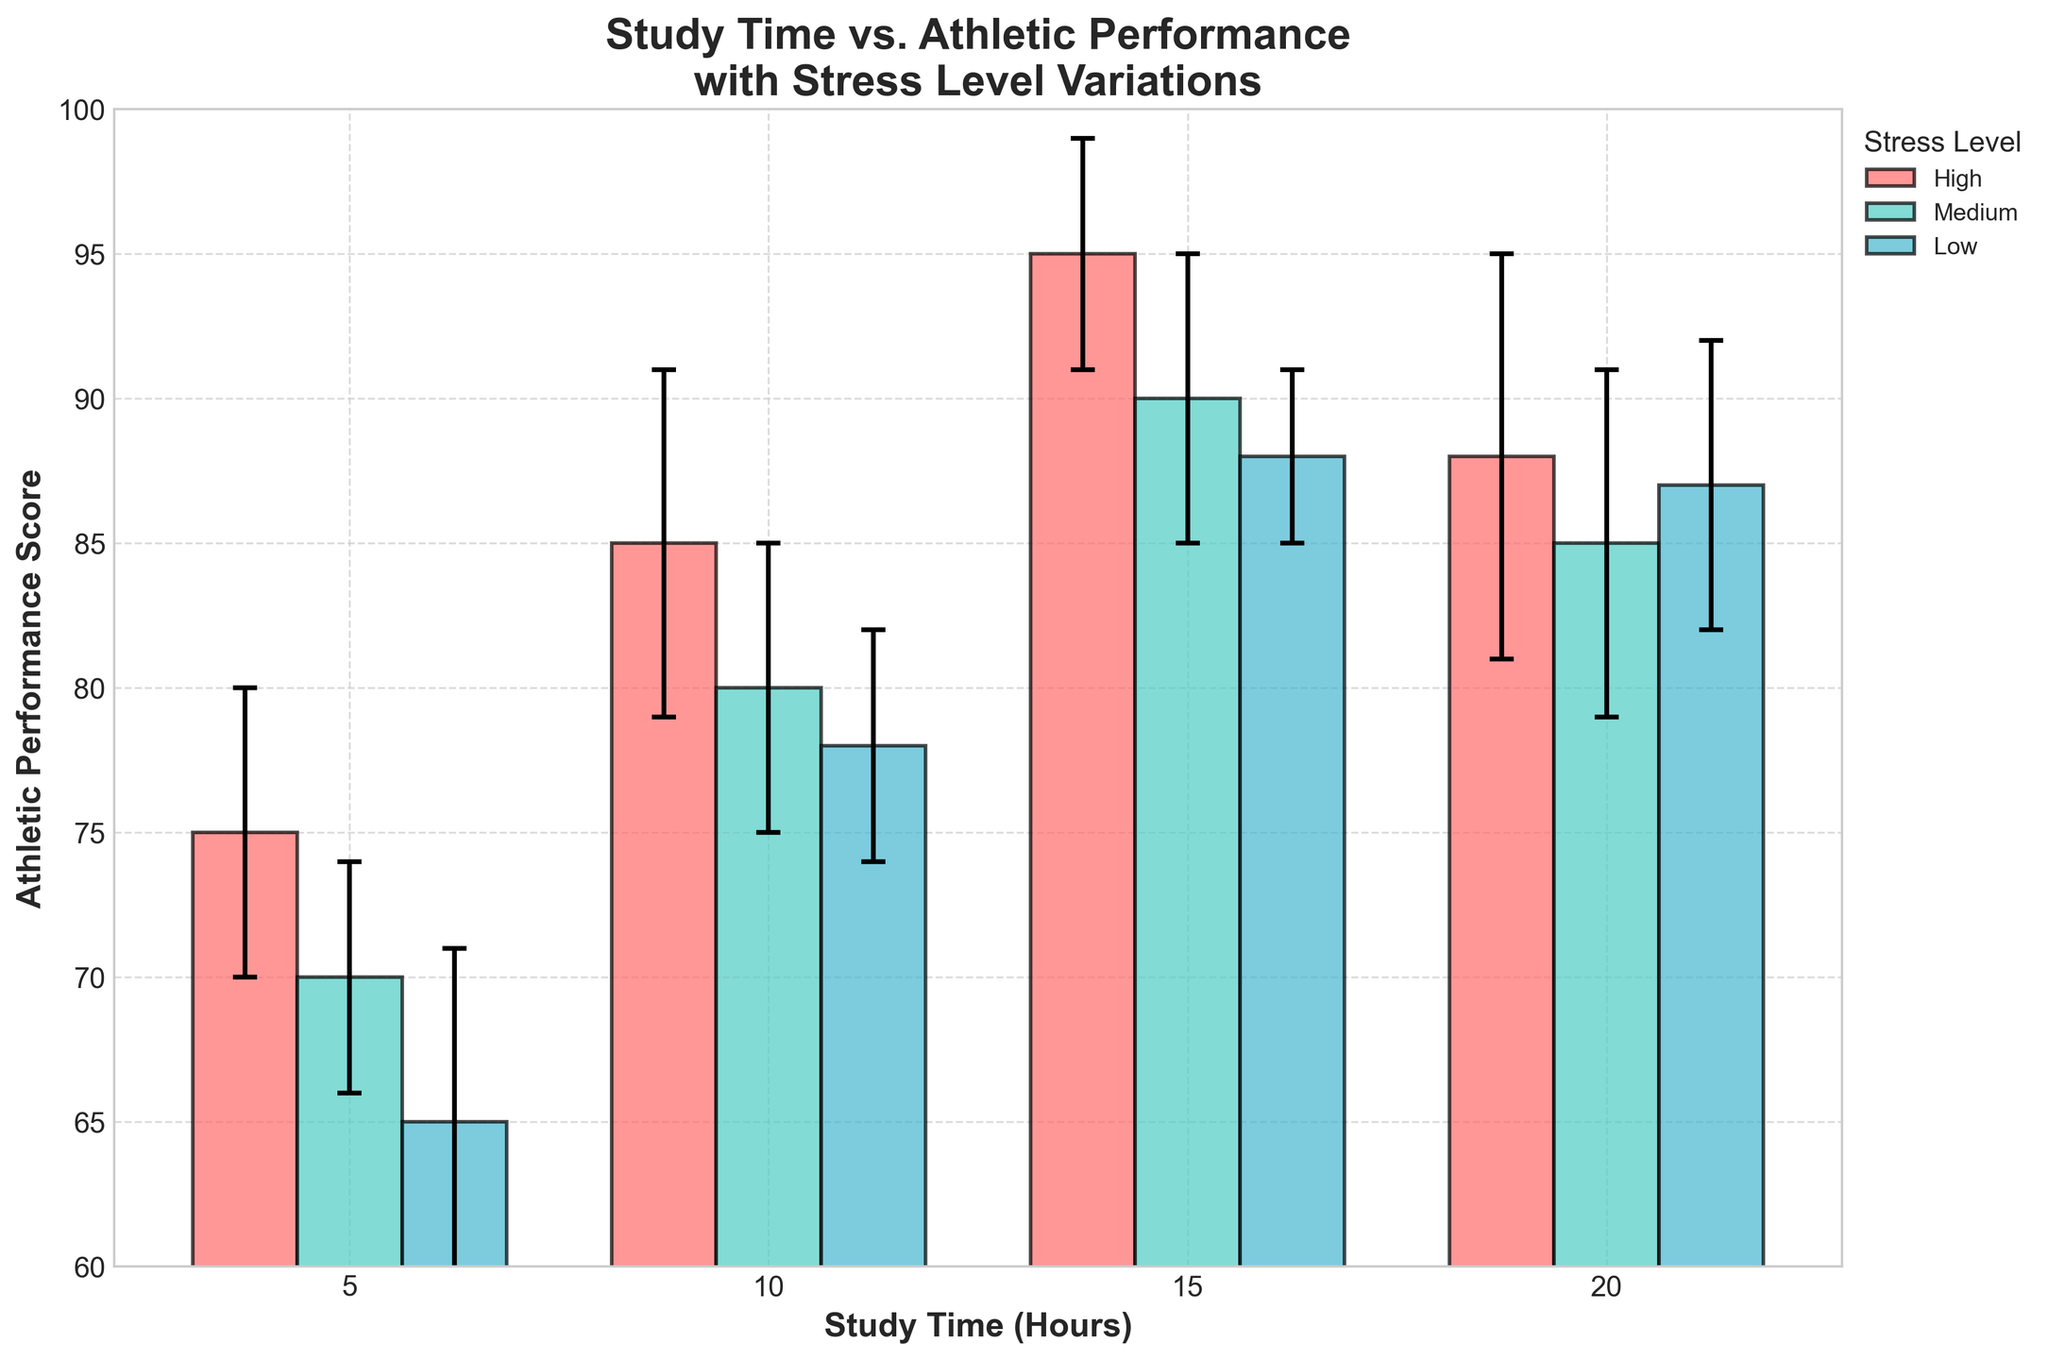What is the title of the chart? The title is written at the top of the chart. It states: "Study Time vs. Athletic Performance with Stress Level Variations".
Answer: Study Time vs. Athletic Performance with Stress Level Variations Which stress level has the highest athletic performance score for 10 hours of study time? Look at the bar heights for 10 hours of study time. The tallest bar indicates the highest performance score. The "High" stress level bar is the tallest.
Answer: High What are the athletic performance scores for 15 hours of study time across different stress levels? Locate the bars that correspond to 15 hours of study time. Note the heights of the bars for each stress level (High, Medium, Low): High (95), Medium (90), Low (88).
Answer: 95, 90, 88 How do the error bars for 5 and 15 hours of study time under "Low" stress compare? Observe the vertical lines on top of the bars for 5 and 15 hours under "Low" stress. Compare their lengths. Error bar for 5 hours is longer.
Answer: Error bar for 5 hours is longer Which study time shows the smallest variation in athletic performance for any stress level? Look at the error bars for each study time under each stress level. The shortest error bar indicates the smallest variation. For the "Low" stress level and 15 hours of study time, the error bar is shortest.
Answer: 15 hours under Low stress What is the difference in athletic performance scores between "High" and "Medium" stress levels for 20 hours of study time? Identify the bars for 20 hours under "High" and "Medium" stress. Subtract the performance score of "Medium" from "High" (88 - 85).
Answer: 3 Which stress level has the greatest decrease in athletic performance score from 15 to 20 hours of study time? Calculate the difference for each stress level: High (95-88=7), Medium (90-85=5), Low (88-87=1). The "High" stress level shows the greatest decrease.
Answer: High Identify the study time where "Medium" stress level always has lower performance scores compared to "High" stress level. Check performance scores for "Medium" and "High" stress levels across all study times: 5, 10, 15, 20. "Medium" scores are consistently lower.
Answer: All study times How does the error bar for "Medium" stress at 20 hours compare to the error bar for "High" stress at 10 hours? Compare the lengths of the error bars. The error bar for "Medium" stress at 20 hours is slightly shorter than the one for "High" stress at 10 hours.
Answer: Slightly shorter 